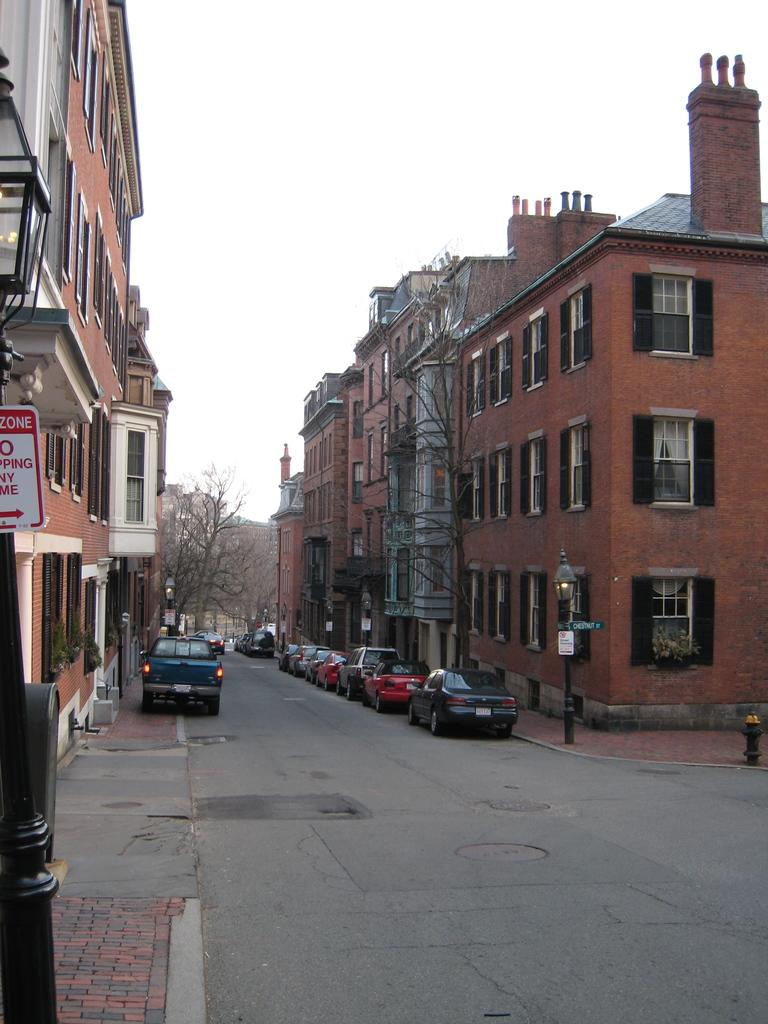What can be seen beside the road in the image? There are vehicles parked beside the road in the image. What is located behind the parked vehicles? There are buildings behind the parked vehicles in the image. What type of natural scenery is visible in the background of the image? There are trees visible in the background of the image. What color crayon is being used to draw on the plastic in the image? There is no crayon or plastic present in the image. Can you touch the trees visible in the background of the image? The image is a photograph or digital representation, so you cannot physically touch the trees in the image. 